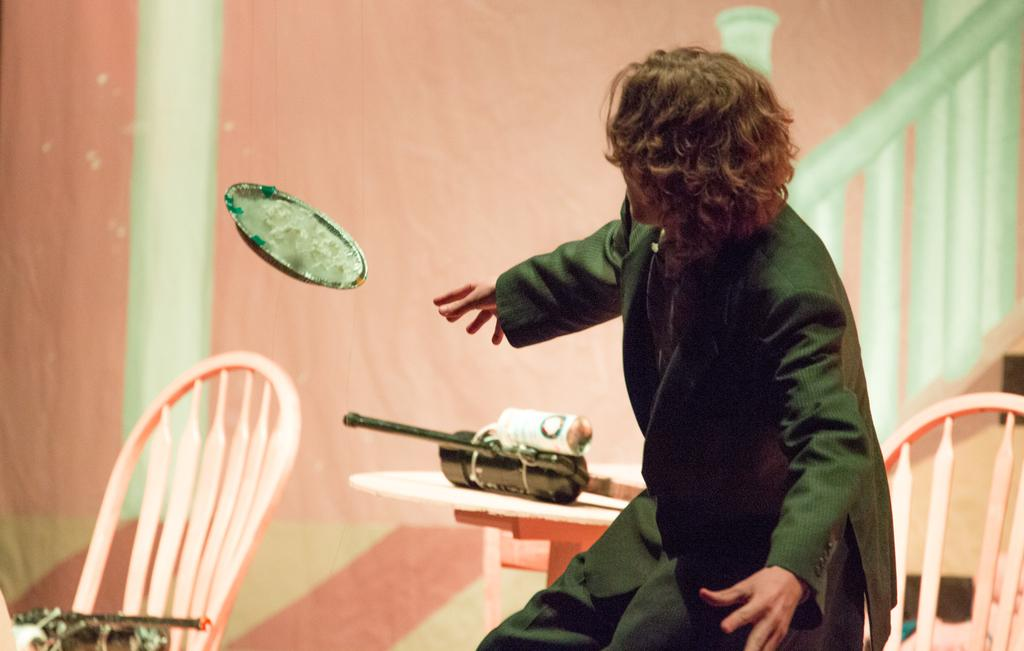Who is present in the image? There is a man in the image. What is the man wearing? The man is wearing a black suit. What can be seen in the background of the image? There are chairs, tables, a wall, and some objects in the background of the image. What is the man's income in the image? There is no information about the man's income in the image. Can you tell me how the man is swimming in the image? There is no swimming activity depicted in the image; the man is wearing a black suit and standing or sitting. 